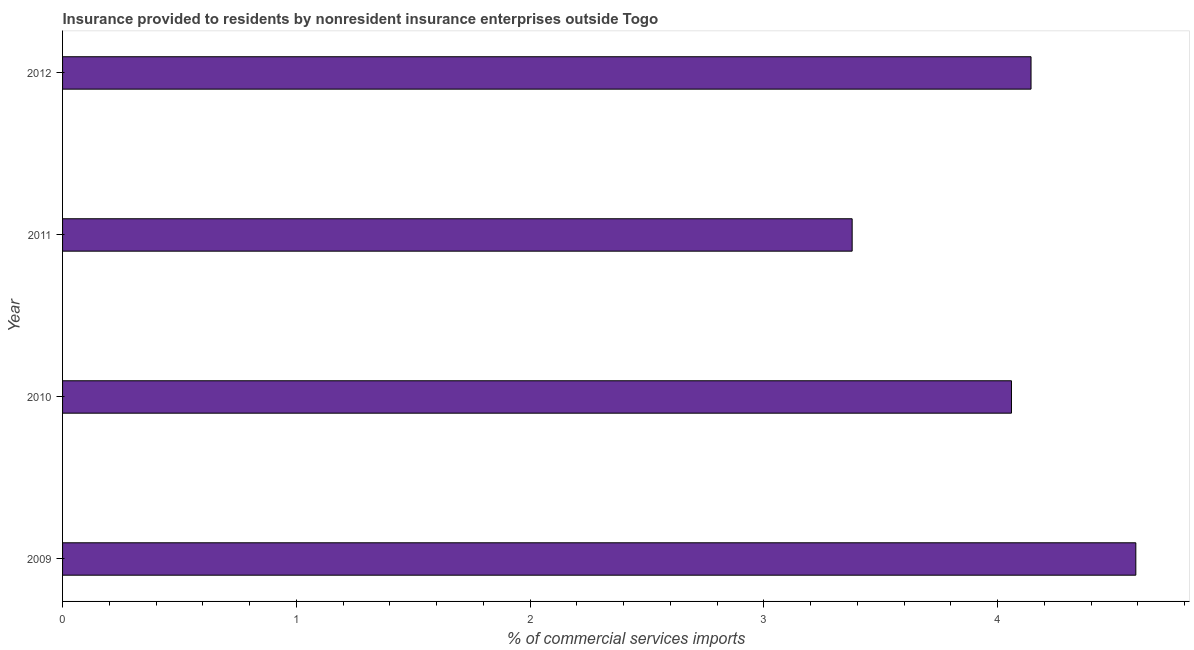Does the graph contain any zero values?
Your response must be concise. No. What is the title of the graph?
Provide a succinct answer. Insurance provided to residents by nonresident insurance enterprises outside Togo. What is the label or title of the X-axis?
Your answer should be very brief. % of commercial services imports. What is the insurance provided by non-residents in 2009?
Provide a short and direct response. 4.59. Across all years, what is the maximum insurance provided by non-residents?
Ensure brevity in your answer.  4.59. Across all years, what is the minimum insurance provided by non-residents?
Make the answer very short. 3.38. In which year was the insurance provided by non-residents maximum?
Your answer should be very brief. 2009. In which year was the insurance provided by non-residents minimum?
Provide a succinct answer. 2011. What is the sum of the insurance provided by non-residents?
Offer a very short reply. 16.17. What is the difference between the insurance provided by non-residents in 2009 and 2010?
Your answer should be very brief. 0.53. What is the average insurance provided by non-residents per year?
Make the answer very short. 4.04. What is the median insurance provided by non-residents?
Keep it short and to the point. 4.1. What is the ratio of the insurance provided by non-residents in 2009 to that in 2010?
Offer a very short reply. 1.13. What is the difference between the highest and the second highest insurance provided by non-residents?
Give a very brief answer. 0.45. What is the difference between the highest and the lowest insurance provided by non-residents?
Offer a very short reply. 1.21. How many bars are there?
Ensure brevity in your answer.  4. How many years are there in the graph?
Give a very brief answer. 4. Are the values on the major ticks of X-axis written in scientific E-notation?
Offer a very short reply. No. What is the % of commercial services imports of 2009?
Your response must be concise. 4.59. What is the % of commercial services imports in 2010?
Provide a succinct answer. 4.06. What is the % of commercial services imports in 2011?
Keep it short and to the point. 3.38. What is the % of commercial services imports in 2012?
Provide a succinct answer. 4.14. What is the difference between the % of commercial services imports in 2009 and 2010?
Provide a short and direct response. 0.53. What is the difference between the % of commercial services imports in 2009 and 2011?
Provide a succinct answer. 1.21. What is the difference between the % of commercial services imports in 2009 and 2012?
Your answer should be very brief. 0.45. What is the difference between the % of commercial services imports in 2010 and 2011?
Your answer should be very brief. 0.68. What is the difference between the % of commercial services imports in 2010 and 2012?
Make the answer very short. -0.08. What is the difference between the % of commercial services imports in 2011 and 2012?
Provide a short and direct response. -0.77. What is the ratio of the % of commercial services imports in 2009 to that in 2010?
Your answer should be compact. 1.13. What is the ratio of the % of commercial services imports in 2009 to that in 2011?
Ensure brevity in your answer.  1.36. What is the ratio of the % of commercial services imports in 2009 to that in 2012?
Provide a succinct answer. 1.11. What is the ratio of the % of commercial services imports in 2010 to that in 2011?
Offer a very short reply. 1.2. What is the ratio of the % of commercial services imports in 2011 to that in 2012?
Your response must be concise. 0.81. 